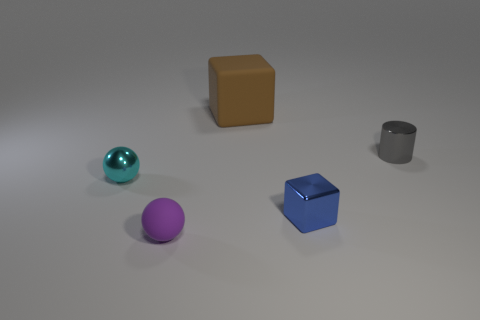Add 1 metal balls. How many objects exist? 6 Subtract all cylinders. How many objects are left? 4 Add 4 tiny purple things. How many tiny purple things exist? 5 Subtract 0 purple cylinders. How many objects are left? 5 Subtract all tiny gray metallic objects. Subtract all tiny purple spheres. How many objects are left? 3 Add 3 large brown blocks. How many large brown blocks are left? 4 